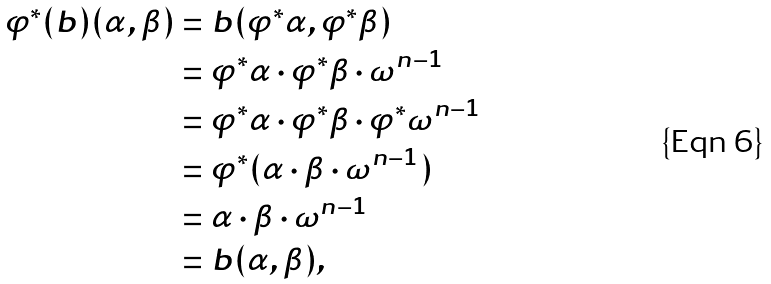Convert formula to latex. <formula><loc_0><loc_0><loc_500><loc_500>\varphi ^ { * } ( b ) ( \alpha , \beta ) & = b ( \varphi ^ { * } \alpha , \varphi ^ { * } \beta ) \\ & = \varphi ^ { * } \alpha \cdot \varphi ^ { * } \beta \cdot \omega ^ { n - 1 } \\ & = \varphi ^ { * } \alpha \cdot \varphi ^ { * } \beta \cdot \varphi ^ { * } \omega ^ { n - 1 } \\ & = \varphi ^ { * } ( \alpha \cdot \beta \cdot \omega ^ { n - 1 } ) \\ & = \alpha \cdot \beta \cdot \omega ^ { n - 1 } \\ & = b ( \alpha , \beta ) ,</formula> 